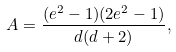Convert formula to latex. <formula><loc_0><loc_0><loc_500><loc_500>A = \frac { ( e ^ { 2 } - 1 ) ( 2 e ^ { 2 } - 1 ) } { d ( d + 2 ) } ,</formula> 